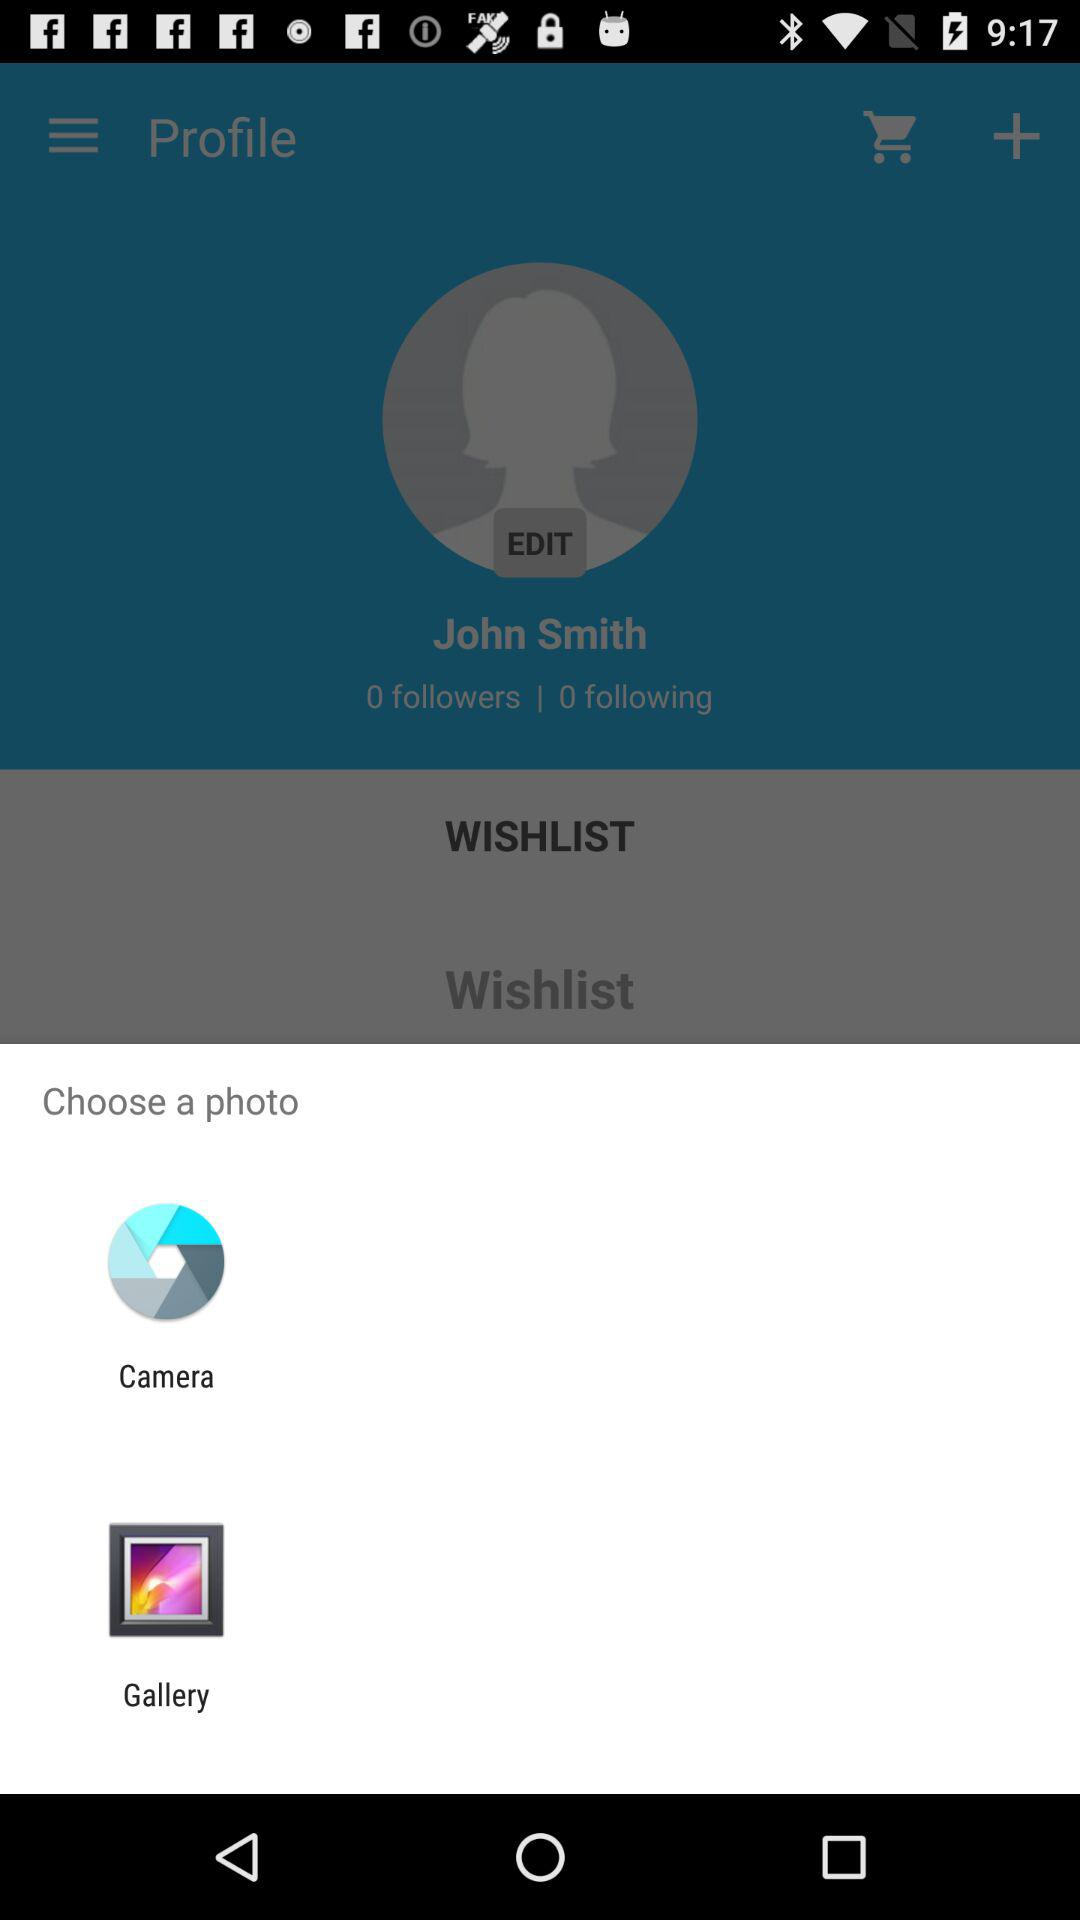How many followers are there? There are 0 followers. 